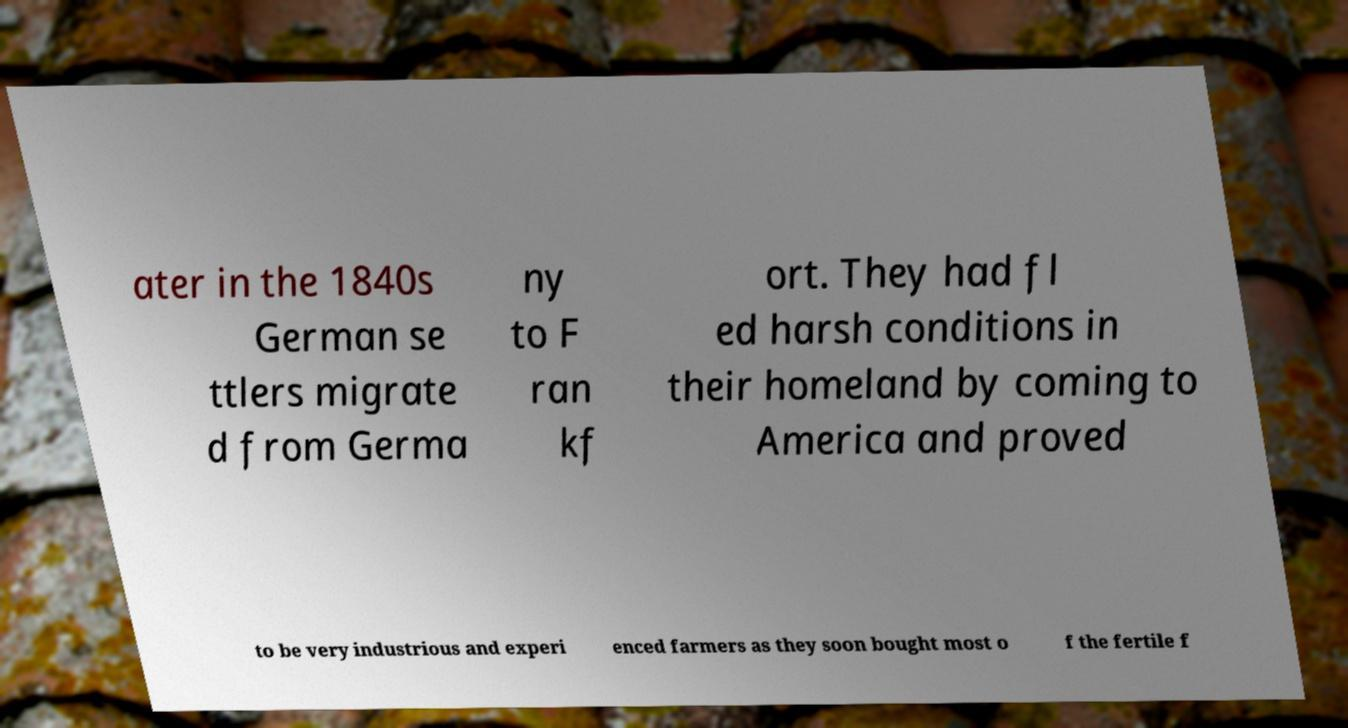What messages or text are displayed in this image? I need them in a readable, typed format. ater in the 1840s German se ttlers migrate d from Germa ny to F ran kf ort. They had fl ed harsh conditions in their homeland by coming to America and proved to be very industrious and experi enced farmers as they soon bought most o f the fertile f 